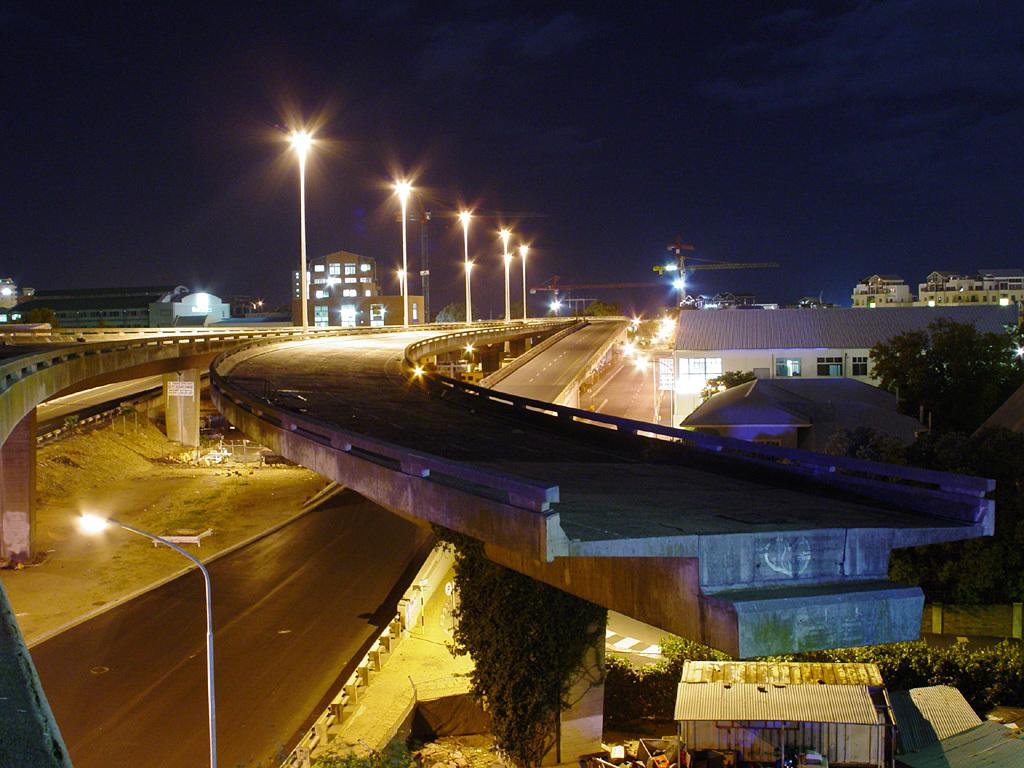What type of structures can be seen in the image? There are buildings in the image. What other natural elements are present in the image? There are trees in the image. What type of transportation infrastructure is visible in the image? Flyovers with street lights are visible in the image. What can be seen in the background of the image? The sky is visible in the background of the image. What construction equipment is present in the image? There are two tower cranes in the image. Can you hear the baby crying in the image? There is no baby present in the image, so it is not possible to hear a baby crying. What type of blade is being used by the tower cranes in the image? The image does not show any blades associated with the tower cranes; they are lifting and moving objects using cables and hooks. 